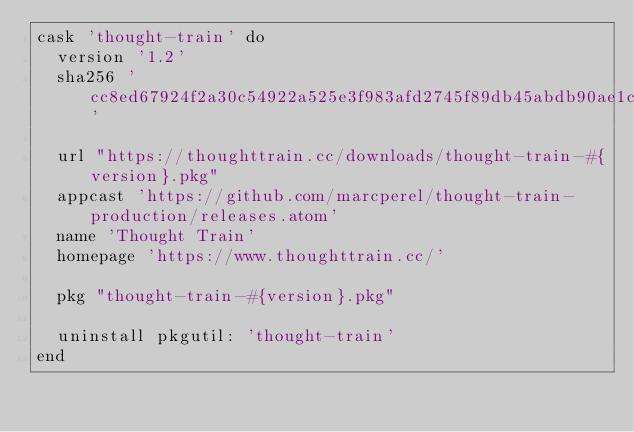<code> <loc_0><loc_0><loc_500><loc_500><_Ruby_>cask 'thought-train' do
  version '1.2'
  sha256 'cc8ed67924f2a30c54922a525e3f983afd2745f89db45abdb90ae1c9a12a631c'

  url "https://thoughttrain.cc/downloads/thought-train-#{version}.pkg"
  appcast 'https://github.com/marcperel/thought-train-production/releases.atom'
  name 'Thought Train'
  homepage 'https://www.thoughttrain.cc/'

  pkg "thought-train-#{version}.pkg"

  uninstall pkgutil: 'thought-train'
end
</code> 